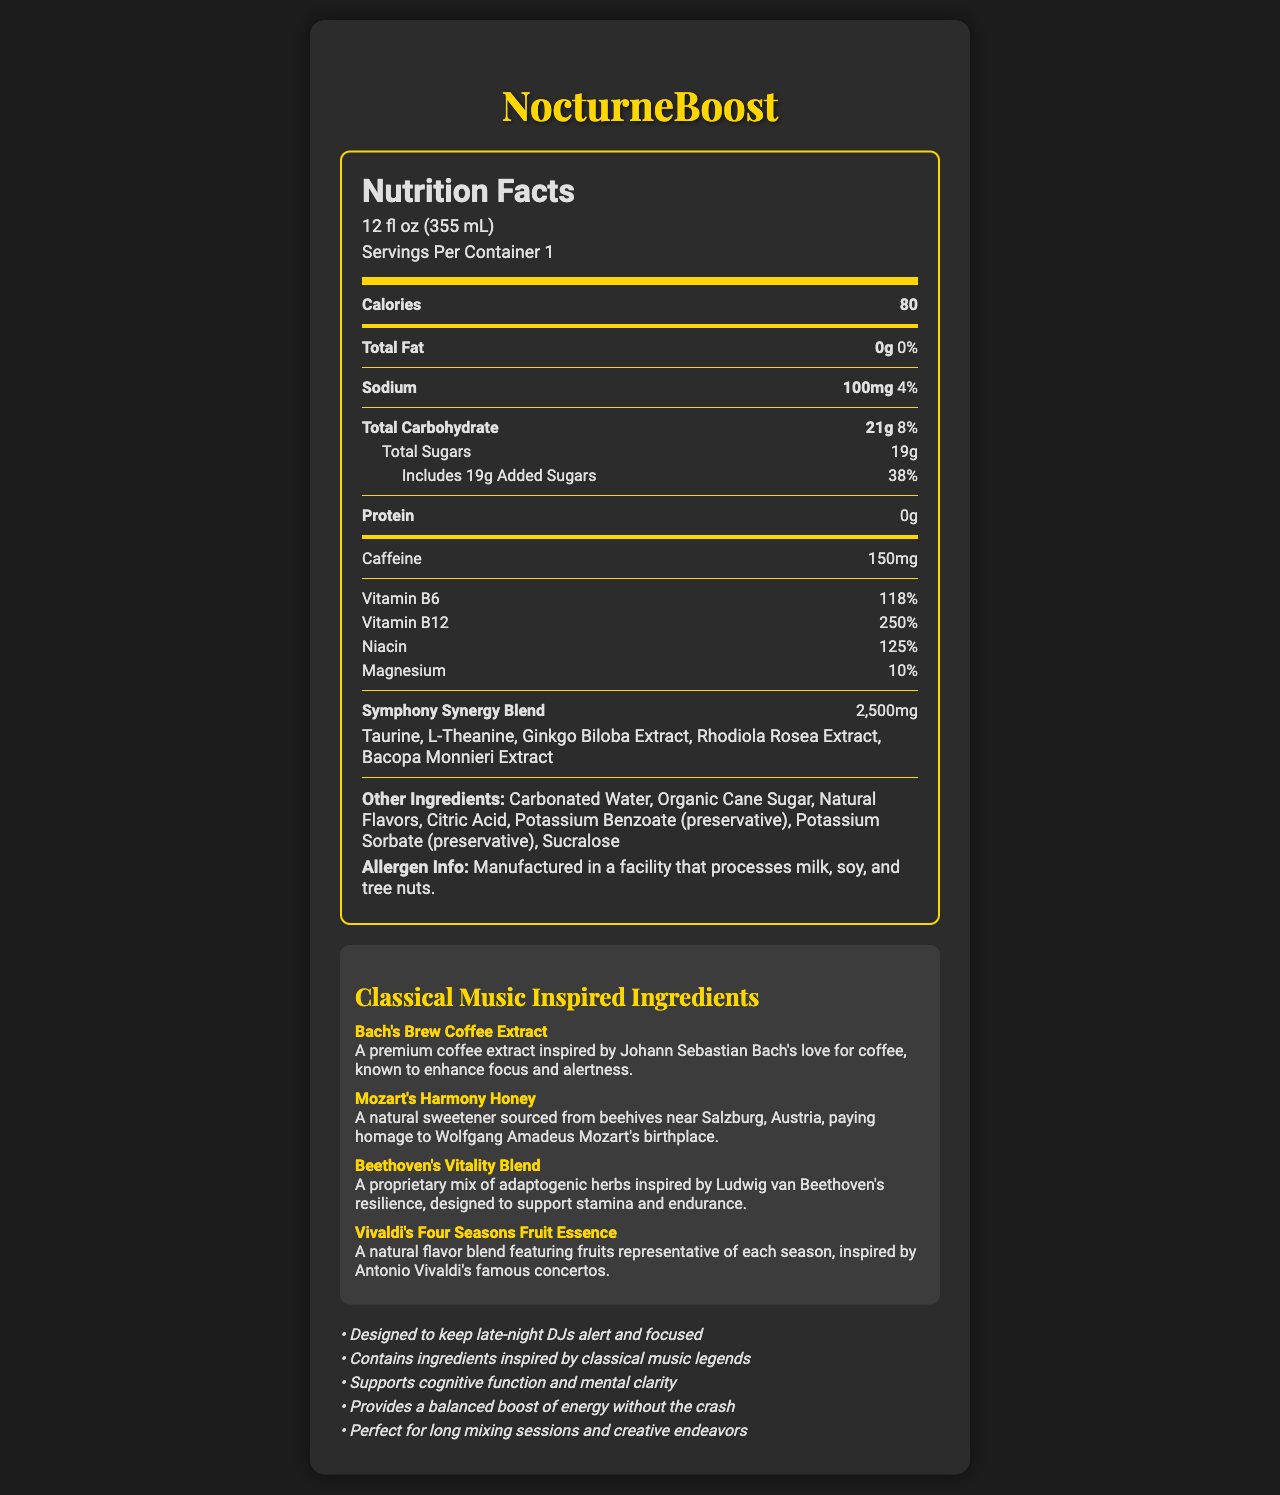what is the serving size of NocturneBoost? The serving size is listed directly under the product name "NocturneBoost" in the Nutrition Facts section.
Answer: 12 fl oz (355 mL) how many calories are in one serving of NocturneBoost? The number of calories is specified under the "Calories" label in the Nutrition Facts section.
Answer: 80 what percent of the daily value of sodium is in one serving of NocturneBoost? The daily value of sodium is given as "4%" under the "Sodium" label in the Nutrition Facts section.
Answer: 4% how much caffeine is in one serving of NocturneBoost? The caffeine content is listed in the Nutrition Facts section under "Caffeine."
Answer: 150mg how many grams of added sugars are in NocturneBoost? The amount of added sugars is shown under the "Total Carbohydrate" section in the Nutrition Facts.
Answer: 19g which vitamin in NocturneBoost has the highest daily value percentage? A. Vitamin B6 B. Vitamin B12 C. Niacin D. Magnesium The Nutrition Facts section lists Vitamin B12 with a daily value of "250%," which is higher than the other vitamins listed.
Answer: B. Vitamin B12 which ingredient in the Symphony Synergy Blend is known to support cognitive function? A. Taurine B. L-Theanine C. Ginkgo Biloba Extract D. Bacopa Monnieri Extract Ginkgo Biloba Extract is commonly known to support cognitive function, as identified in the list of ingredients under the proprietary blend section.
Answer: C. Ginkgo Biloba Extract is NocturneBoost suitable for someone with a nut allergy? The allergen information indicates that the product is "Manufactured in a facility that processes milk, soy, and tree nuts," which may not be suitable for someone with a nut allergy.
Answer: No describe the main focus of the NocturneBoost document. The document serves to inform potential consumers about the nutritional content, special ingredients inspired by classical musicians, and the intended benefits of consuming the drink, such as increased alertness and cognitive function.
Answer: The document details the Nutrition Facts for NocturneBoost, an energy drink designed for late-night DJs. It highlights the serving size, nutritional information, proprietary blend ingredients, classical music-inspired ingredients, and marketing claims. what are the classical music-inspired ingredients in NocturneBoost? These ingredients are specifically listed under the "Classical Music Inspired Ingredients" section with brief descriptions.
Answer: Bach's Brew Coffee Extract, Mozart's Harmony Honey, Beethoven's Vitality Blend, Vivaldi's Four Seasons Fruit Essence what is the proprietary blend in NocturneBoost called? The proprietary blend is mentioned under the "Symphony Synergy Blend" in the Nutrition Facts section along with its ingredients.
Answer: Symphony Synergy Blend how much protein does one serving of NocturneBoost contain? The protein content is listed as "0g" in the Nutrition Facts section.
Answer: 0g what is the total carbohydrate content in one serving of NocturneBoost? The total carbohydrate content is mentioned under "Total Carbohydrate" in the Nutrition Facts section.
Answer: 21g what type of preservative is found in NocturneBoost? A. Sodium Benzoate B. Potassium Benzoate C. Sorbic Acid D. Sodium Nitrite The list of other ingredients includes "Potassium Benzoate (preservative)."
Answer: B. Potassium Benzoate why might a late-night DJ choose NocturneBoost? Several marketing claims highlight the benefits of NocturneBoost for late-night DJs, such as increased alertness, cognitive support, and sustained energy.
Answer: To stay alert and focused, improve cognitive function, and get a balanced boost of energy without the crash. does the document provide information about the caffeine source in NocturneBoost? The document lists the amount of caffeine but does not specify the source of the caffeine.
Answer: Not enough information how does Bach's Brew Coffee Extract benefit users? The description under the "Classical Music Inspired Ingredients" section states that Bach's Brew Coffee Extract is designed to enhance focus and alertness.
Answer: Enhances focus and alertness what are the preservative ingredients in NocturneBoost? Both preservatives are listed under the "Other Ingredients" section in the Nutrition Facts.
Answer: Potassium Benzoate and Potassium Sorbate which ingredient is not part of the proprietary blend? A. Taurine B. Rhodiola Rosea Extract C. Bacopa Monnieri Extract D. Sucralose Sucralose is listed as one of the other ingredients, not part of the Symphony Synergy Blend.
Answer: D. Sucralose is NocturneBoost vegan-friendly? The document does not provide enough information to determine whether NocturneBoost is vegan-friendly or not.
Answer: Cannot be determined 